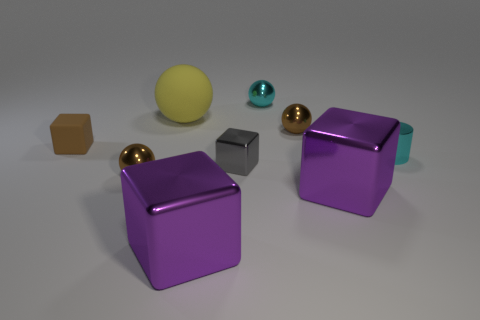Do the tiny rubber block and the metal cylinder have the same color?
Provide a short and direct response. No. What number of objects are either tiny metal blocks left of the small cyan shiny ball or metallic things?
Ensure brevity in your answer.  7. The rubber thing that is the same size as the gray block is what shape?
Offer a terse response. Cube. Does the matte thing in front of the yellow thing have the same size as the shiny ball on the left side of the big matte object?
Make the answer very short. Yes. What is the color of the cube that is the same material as the yellow sphere?
Your answer should be compact. Brown. Does the brown object in front of the tiny gray shiny cube have the same material as the tiny block that is in front of the small brown matte thing?
Keep it short and to the point. Yes. Is there a red rubber object that has the same size as the cyan shiny sphere?
Make the answer very short. No. What size is the purple object that is left of the large purple object right of the tiny cyan metal ball?
Keep it short and to the point. Large. What number of large matte things are the same color as the rubber sphere?
Ensure brevity in your answer.  0. What shape is the brown object right of the cyan thing that is behind the big yellow rubber sphere?
Provide a succinct answer. Sphere. 